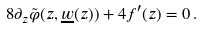Convert formula to latex. <formula><loc_0><loc_0><loc_500><loc_500>8 \partial _ { z } \tilde { \varphi } ( z , \underline { w } ( z ) ) + 4 f ^ { \prime } ( z ) = 0 \, .</formula> 